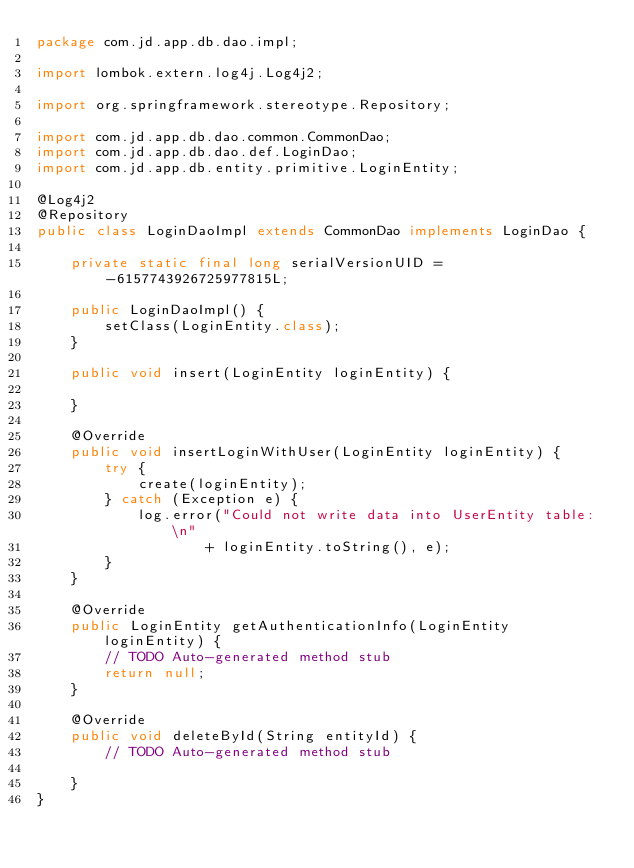Convert code to text. <code><loc_0><loc_0><loc_500><loc_500><_Java_>package com.jd.app.db.dao.impl;

import lombok.extern.log4j.Log4j2;

import org.springframework.stereotype.Repository;

import com.jd.app.db.dao.common.CommonDao;
import com.jd.app.db.dao.def.LoginDao;
import com.jd.app.db.entity.primitive.LoginEntity;

@Log4j2
@Repository
public class LoginDaoImpl extends CommonDao implements LoginDao {

	private static final long serialVersionUID = -6157743926725977815L;

	public LoginDaoImpl() {
		setClass(LoginEntity.class);
	}

	public void insert(LoginEntity loginEntity) {

	}

	@Override
	public void insertLoginWithUser(LoginEntity loginEntity) {
		try {
			create(loginEntity);
		} catch (Exception e) {
			log.error("Could not write data into UserEntity table: \n"
					+ loginEntity.toString(), e);
		}
	}

	@Override
	public LoginEntity getAuthenticationInfo(LoginEntity loginEntity) {
		// TODO Auto-generated method stub
		return null;
	}

	@Override
	public void deleteById(String entityId) {
		// TODO Auto-generated method stub

	}
}
</code> 